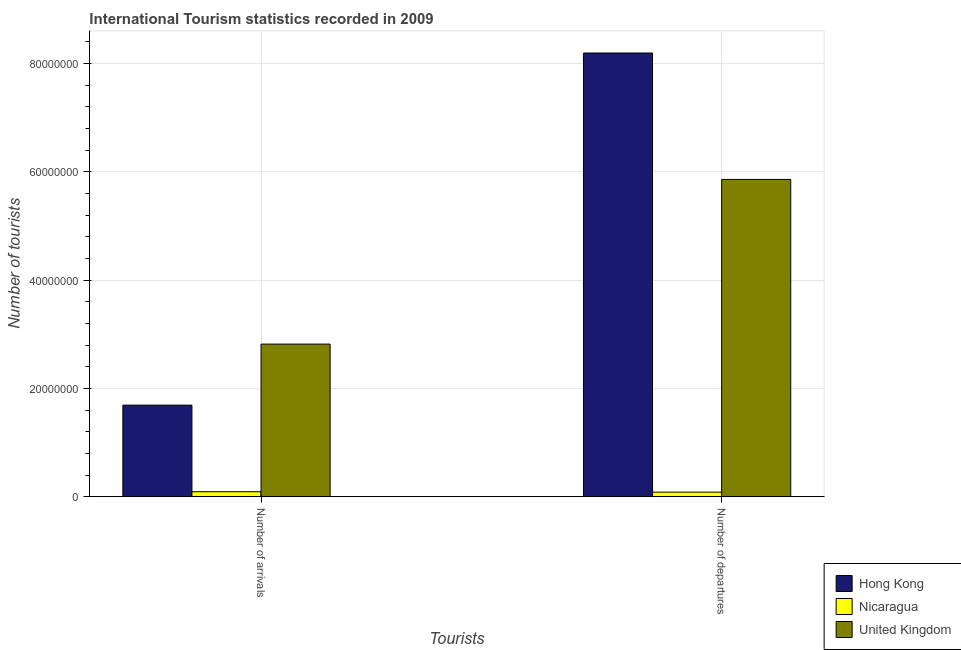How many different coloured bars are there?
Provide a succinct answer. 3. How many groups of bars are there?
Give a very brief answer. 2. Are the number of bars per tick equal to the number of legend labels?
Your response must be concise. Yes. Are the number of bars on each tick of the X-axis equal?
Make the answer very short. Yes. How many bars are there on the 2nd tick from the left?
Provide a short and direct response. 3. What is the label of the 1st group of bars from the left?
Give a very brief answer. Number of arrivals. What is the number of tourist departures in Hong Kong?
Provide a short and direct response. 8.20e+07. Across all countries, what is the maximum number of tourist arrivals?
Offer a very short reply. 2.82e+07. Across all countries, what is the minimum number of tourist arrivals?
Your answer should be compact. 9.32e+05. In which country was the number of tourist departures minimum?
Your answer should be very brief. Nicaragua. What is the total number of tourist departures in the graph?
Provide a succinct answer. 1.41e+08. What is the difference between the number of tourist arrivals in Nicaragua and that in United Kingdom?
Offer a terse response. -2.73e+07. What is the difference between the number of tourist departures in United Kingdom and the number of tourist arrivals in Hong Kong?
Your answer should be compact. 4.17e+07. What is the average number of tourist arrivals per country?
Keep it short and to the point. 1.54e+07. What is the difference between the number of tourist arrivals and number of tourist departures in Hong Kong?
Keep it short and to the point. -6.50e+07. What is the ratio of the number of tourist departures in Hong Kong to that in Nicaragua?
Ensure brevity in your answer.  95.52. In how many countries, is the number of tourist arrivals greater than the average number of tourist arrivals taken over all countries?
Offer a terse response. 2. What does the 3rd bar from the left in Number of departures represents?
Provide a short and direct response. United Kingdom. What does the 2nd bar from the right in Number of departures represents?
Keep it short and to the point. Nicaragua. How many countries are there in the graph?
Your answer should be compact. 3. What is the difference between two consecutive major ticks on the Y-axis?
Your response must be concise. 2.00e+07. Are the values on the major ticks of Y-axis written in scientific E-notation?
Provide a succinct answer. No. Where does the legend appear in the graph?
Provide a short and direct response. Bottom right. How are the legend labels stacked?
Provide a short and direct response. Vertical. What is the title of the graph?
Offer a very short reply. International Tourism statistics recorded in 2009. What is the label or title of the X-axis?
Ensure brevity in your answer.  Tourists. What is the label or title of the Y-axis?
Provide a succinct answer. Number of tourists. What is the Number of tourists in Hong Kong in Number of arrivals?
Your answer should be compact. 1.69e+07. What is the Number of tourists in Nicaragua in Number of arrivals?
Provide a short and direct response. 9.32e+05. What is the Number of tourists of United Kingdom in Number of arrivals?
Ensure brevity in your answer.  2.82e+07. What is the Number of tourists in Hong Kong in Number of departures?
Offer a terse response. 8.20e+07. What is the Number of tourists in Nicaragua in Number of departures?
Give a very brief answer. 8.58e+05. What is the Number of tourists in United Kingdom in Number of departures?
Your response must be concise. 5.86e+07. Across all Tourists, what is the maximum Number of tourists in Hong Kong?
Provide a succinct answer. 8.20e+07. Across all Tourists, what is the maximum Number of tourists in Nicaragua?
Keep it short and to the point. 9.32e+05. Across all Tourists, what is the maximum Number of tourists in United Kingdom?
Keep it short and to the point. 5.86e+07. Across all Tourists, what is the minimum Number of tourists in Hong Kong?
Provide a succinct answer. 1.69e+07. Across all Tourists, what is the minimum Number of tourists of Nicaragua?
Offer a very short reply. 8.58e+05. Across all Tourists, what is the minimum Number of tourists of United Kingdom?
Keep it short and to the point. 2.82e+07. What is the total Number of tourists in Hong Kong in the graph?
Offer a terse response. 9.89e+07. What is the total Number of tourists of Nicaragua in the graph?
Provide a succinct answer. 1.79e+06. What is the total Number of tourists in United Kingdom in the graph?
Your answer should be very brief. 8.68e+07. What is the difference between the Number of tourists in Hong Kong in Number of arrivals and that in Number of departures?
Your answer should be compact. -6.50e+07. What is the difference between the Number of tourists of Nicaragua in Number of arrivals and that in Number of departures?
Keep it short and to the point. 7.40e+04. What is the difference between the Number of tourists in United Kingdom in Number of arrivals and that in Number of departures?
Your answer should be compact. -3.04e+07. What is the difference between the Number of tourists of Hong Kong in Number of arrivals and the Number of tourists of Nicaragua in Number of departures?
Make the answer very short. 1.61e+07. What is the difference between the Number of tourists of Hong Kong in Number of arrivals and the Number of tourists of United Kingdom in Number of departures?
Make the answer very short. -4.17e+07. What is the difference between the Number of tourists of Nicaragua in Number of arrivals and the Number of tourists of United Kingdom in Number of departures?
Ensure brevity in your answer.  -5.77e+07. What is the average Number of tourists of Hong Kong per Tourists?
Give a very brief answer. 4.94e+07. What is the average Number of tourists of Nicaragua per Tourists?
Keep it short and to the point. 8.95e+05. What is the average Number of tourists in United Kingdom per Tourists?
Give a very brief answer. 4.34e+07. What is the difference between the Number of tourists in Hong Kong and Number of tourists in Nicaragua in Number of arrivals?
Make the answer very short. 1.60e+07. What is the difference between the Number of tourists in Hong Kong and Number of tourists in United Kingdom in Number of arrivals?
Your response must be concise. -1.13e+07. What is the difference between the Number of tourists in Nicaragua and Number of tourists in United Kingdom in Number of arrivals?
Make the answer very short. -2.73e+07. What is the difference between the Number of tourists of Hong Kong and Number of tourists of Nicaragua in Number of departures?
Your response must be concise. 8.11e+07. What is the difference between the Number of tourists of Hong Kong and Number of tourists of United Kingdom in Number of departures?
Give a very brief answer. 2.33e+07. What is the difference between the Number of tourists of Nicaragua and Number of tourists of United Kingdom in Number of departures?
Keep it short and to the point. -5.78e+07. What is the ratio of the Number of tourists in Hong Kong in Number of arrivals to that in Number of departures?
Your answer should be very brief. 0.21. What is the ratio of the Number of tourists of Nicaragua in Number of arrivals to that in Number of departures?
Give a very brief answer. 1.09. What is the ratio of the Number of tourists of United Kingdom in Number of arrivals to that in Number of departures?
Provide a short and direct response. 0.48. What is the difference between the highest and the second highest Number of tourists of Hong Kong?
Your answer should be compact. 6.50e+07. What is the difference between the highest and the second highest Number of tourists of Nicaragua?
Offer a very short reply. 7.40e+04. What is the difference between the highest and the second highest Number of tourists of United Kingdom?
Offer a terse response. 3.04e+07. What is the difference between the highest and the lowest Number of tourists of Hong Kong?
Provide a short and direct response. 6.50e+07. What is the difference between the highest and the lowest Number of tourists in Nicaragua?
Ensure brevity in your answer.  7.40e+04. What is the difference between the highest and the lowest Number of tourists of United Kingdom?
Offer a terse response. 3.04e+07. 